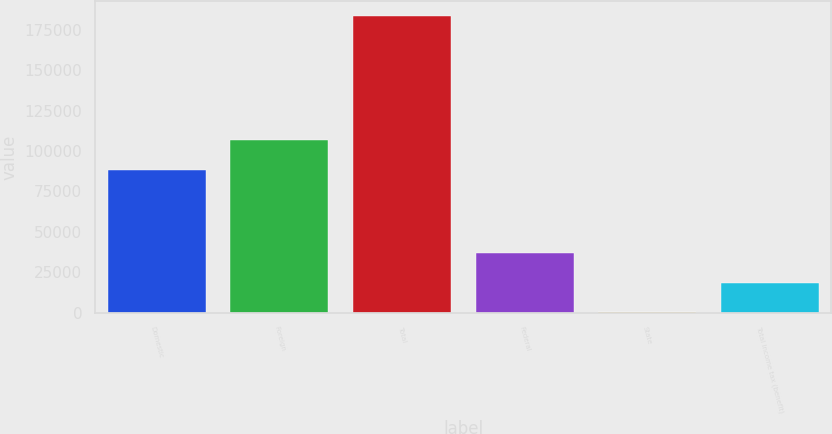Convert chart. <chart><loc_0><loc_0><loc_500><loc_500><bar_chart><fcel>Domestic<fcel>Foreign<fcel>Total<fcel>Federal<fcel>State<fcel>Total income tax (benefit)<nl><fcel>88162<fcel>106470<fcel>183343<fcel>36876.6<fcel>260<fcel>18568.3<nl></chart> 